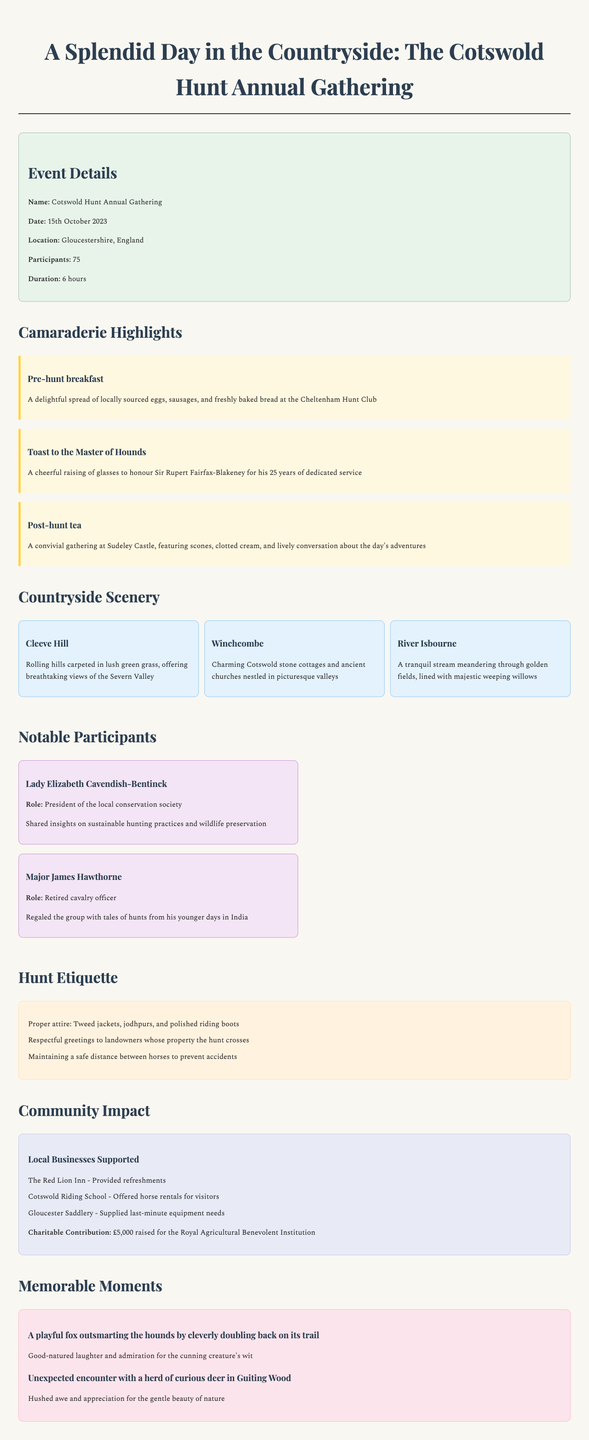What is the name of the event? The name of the event is provided in the document as the title of the gathering.
Answer: Cotswold Hunt Annual Gathering When did the event take place? The date of the event is explicitly mentioned in the event details section.
Answer: 15th October 2023 How long did the hunt last? The duration of the event is stated in the event details.
Answer: 6 hours Who was honoured with a toast during the gathering? The notable participant who received a toast is mentioned specifically in the camaraderie highlights section.
Answer: Sir Rupert Fairfax-Blakeney What is one of the memorable moments during the hunt? The document lists memorable moments, including reactions to playful wildlife interactions.
Answer: A playful fox outsmarting the hounds Which notable participant shared insights on sustainable hunting practices? The contribution of this participant is highlighted alongside their name and role.
Answer: Lady Elizabeth Cavendish-Bentinck What type of clothing is mentioned in the hunt etiquette? The document outlines proper attire as part of the hunt etiquette.
Answer: Tweed jackets, jodhpurs, and polished riding boots Name one location described in the countryside scenery. The document provides various locations notable for their scenic beauty.
Answer: Cleeve Hill What was the charitable contribution raised during the event? The amount raised for charity is specifically noted in the community impact section.
Answer: £5,000 